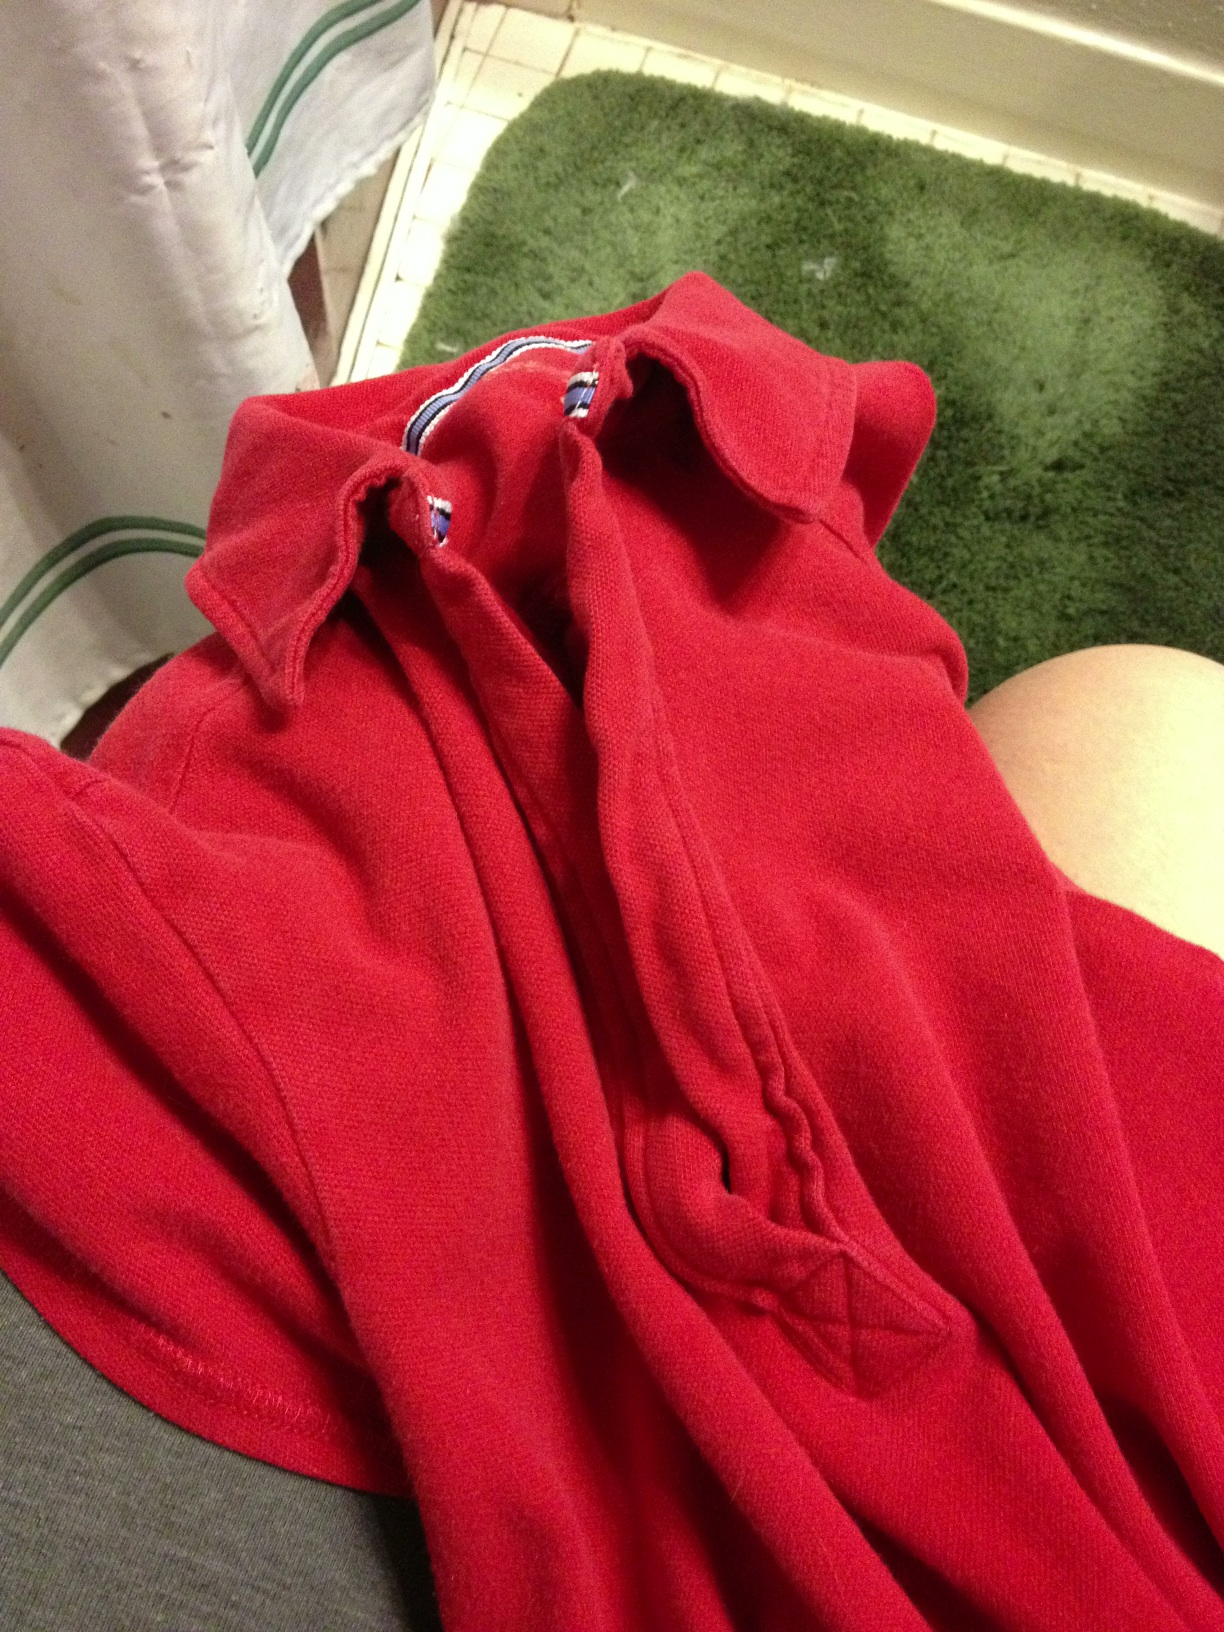Can you tell me if there are any distinctive features or designs on the shirt? From the visible portion of the shirt, there don't seem to be any distinctive patterns or designs—it looks like a classic, solid-colored red shirt. 